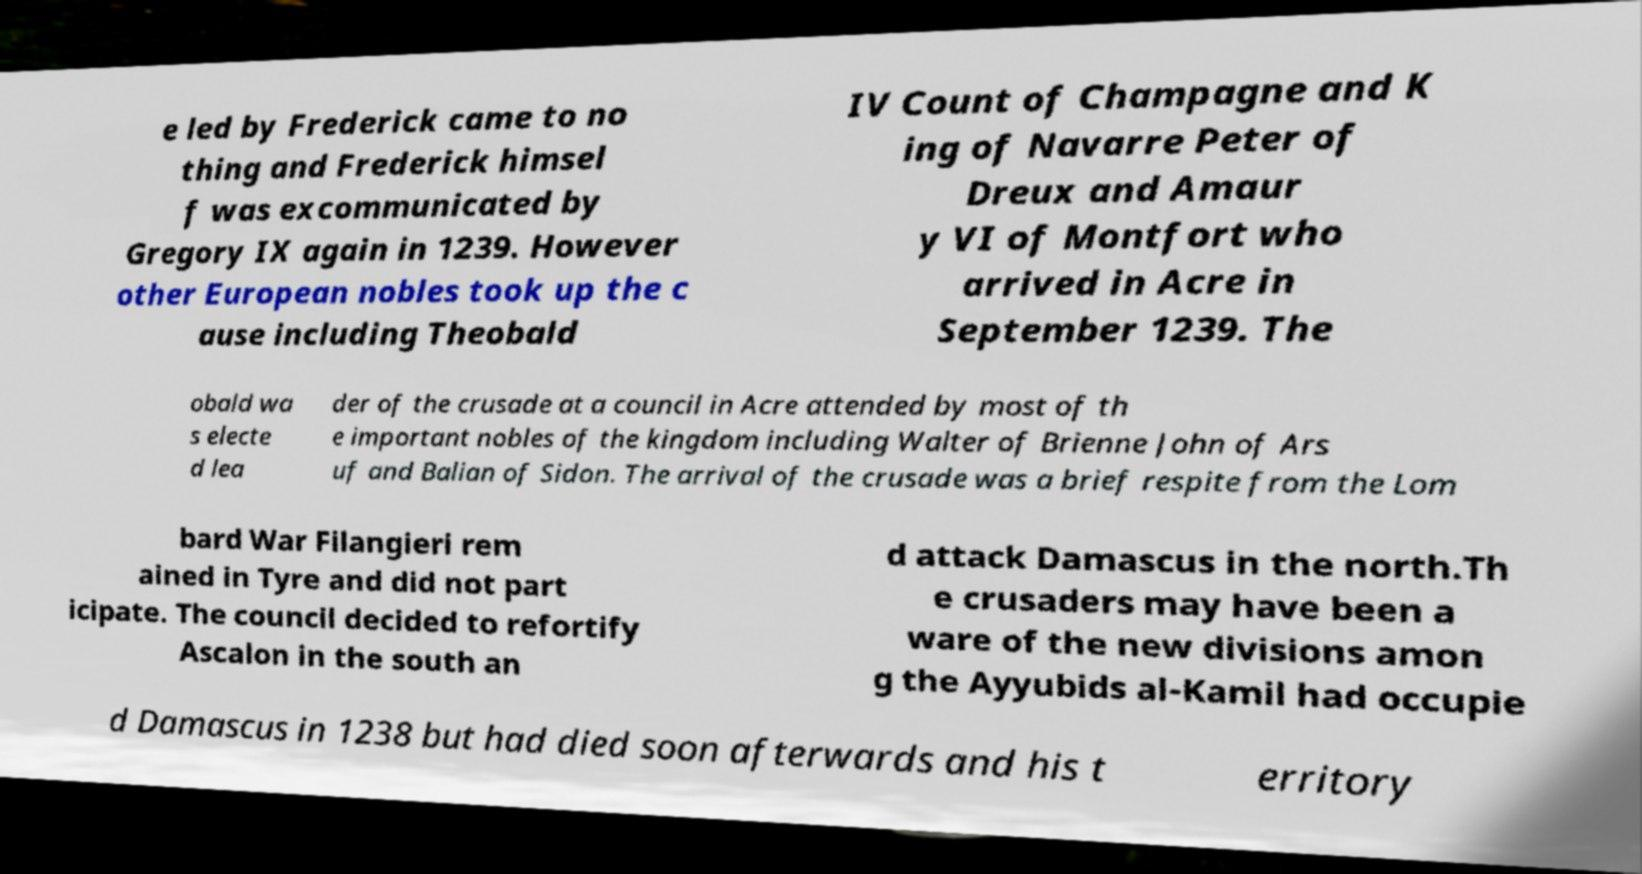Could you assist in decoding the text presented in this image and type it out clearly? e led by Frederick came to no thing and Frederick himsel f was excommunicated by Gregory IX again in 1239. However other European nobles took up the c ause including Theobald IV Count of Champagne and K ing of Navarre Peter of Dreux and Amaur y VI of Montfort who arrived in Acre in September 1239. The obald wa s electe d lea der of the crusade at a council in Acre attended by most of th e important nobles of the kingdom including Walter of Brienne John of Ars uf and Balian of Sidon. The arrival of the crusade was a brief respite from the Lom bard War Filangieri rem ained in Tyre and did not part icipate. The council decided to refortify Ascalon in the south an d attack Damascus in the north.Th e crusaders may have been a ware of the new divisions amon g the Ayyubids al-Kamil had occupie d Damascus in 1238 but had died soon afterwards and his t erritory 